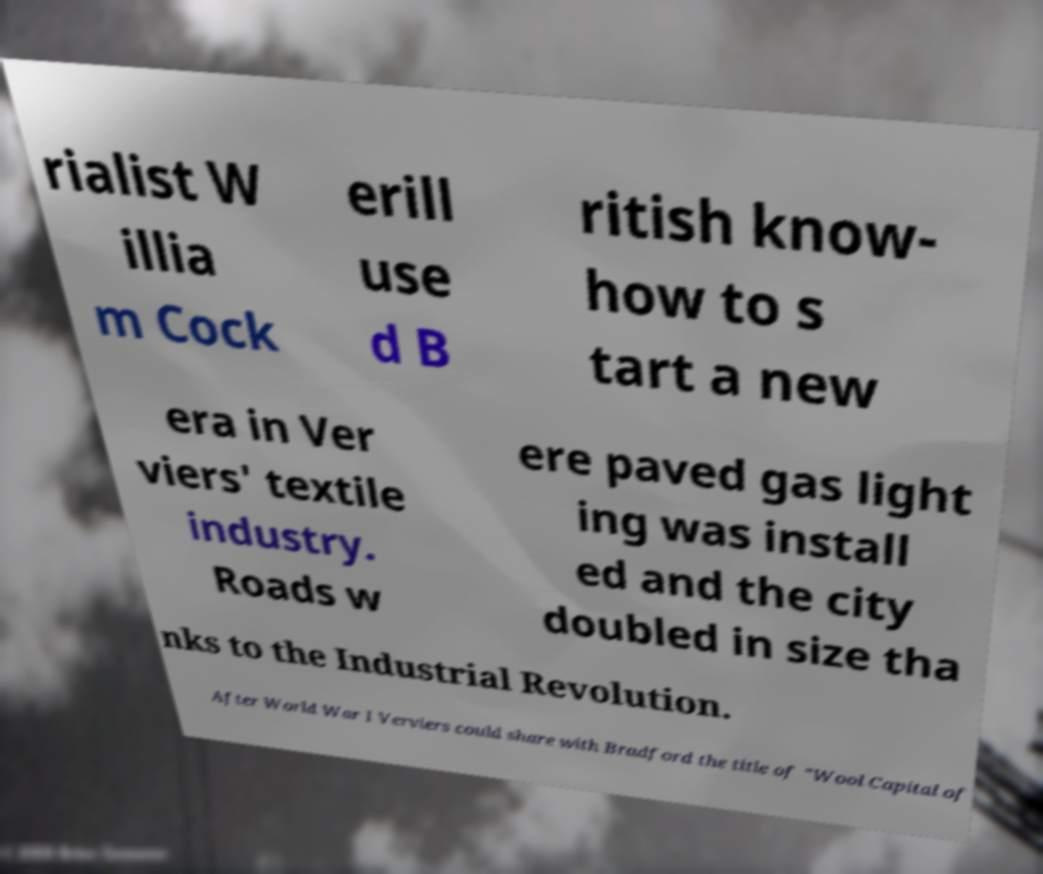Can you accurately transcribe the text from the provided image for me? rialist W illia m Cock erill use d B ritish know- how to s tart a new era in Ver viers' textile industry. Roads w ere paved gas light ing was install ed and the city doubled in size tha nks to the Industrial Revolution. After World War I Verviers could share with Bradford the title of "Wool Capital of 